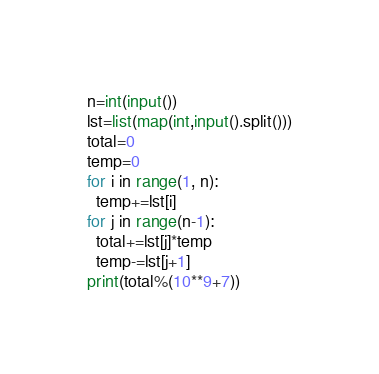<code> <loc_0><loc_0><loc_500><loc_500><_Python_>n=int(input())
lst=list(map(int,input().split()))
total=0
temp=0
for i in range(1, n):
  temp+=lst[i]
for j in range(n-1):
  total+=lst[j]*temp
  temp-=lst[j+1]
print(total%(10**9+7))</code> 